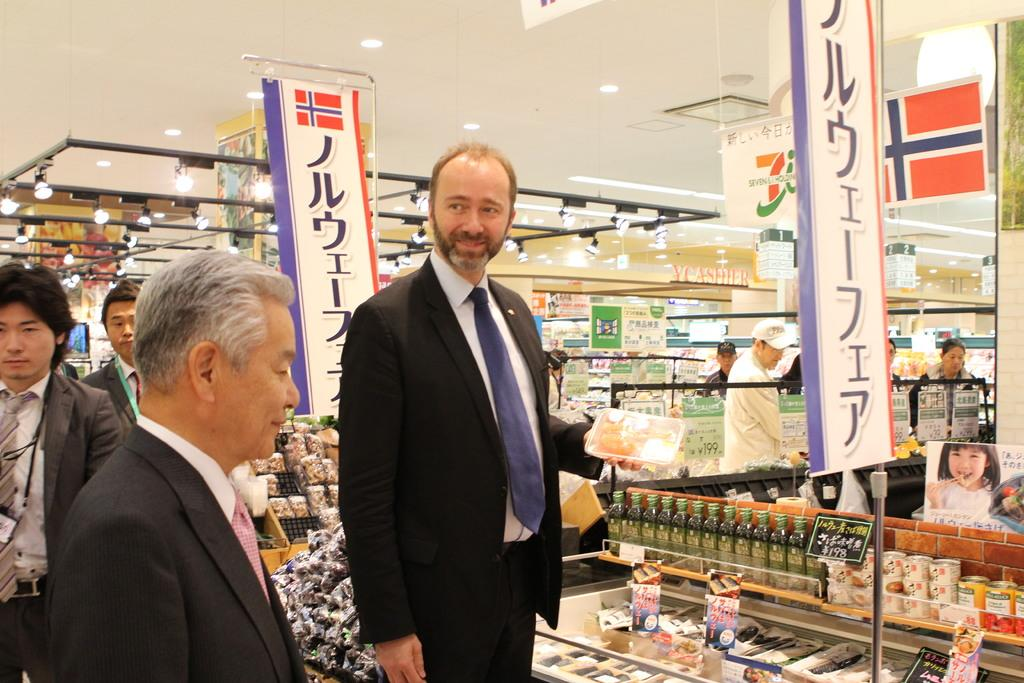What is the main subject of the image? The main subject of the image is a man standing in the middle of the image. What is the man wearing in the image? The man is wearing a black coat and black trousers, as well as a tie. Can you describe the setting of the image? The image appears to be set in a supermarket. What type of hen can be seen interacting with the man in the image? There is no hen present in the image; it features a man standing in a supermarket. What type of structure is the man's father standing next to in the image? There is no father or structure present in the image; it features a man standing in a supermarket. 